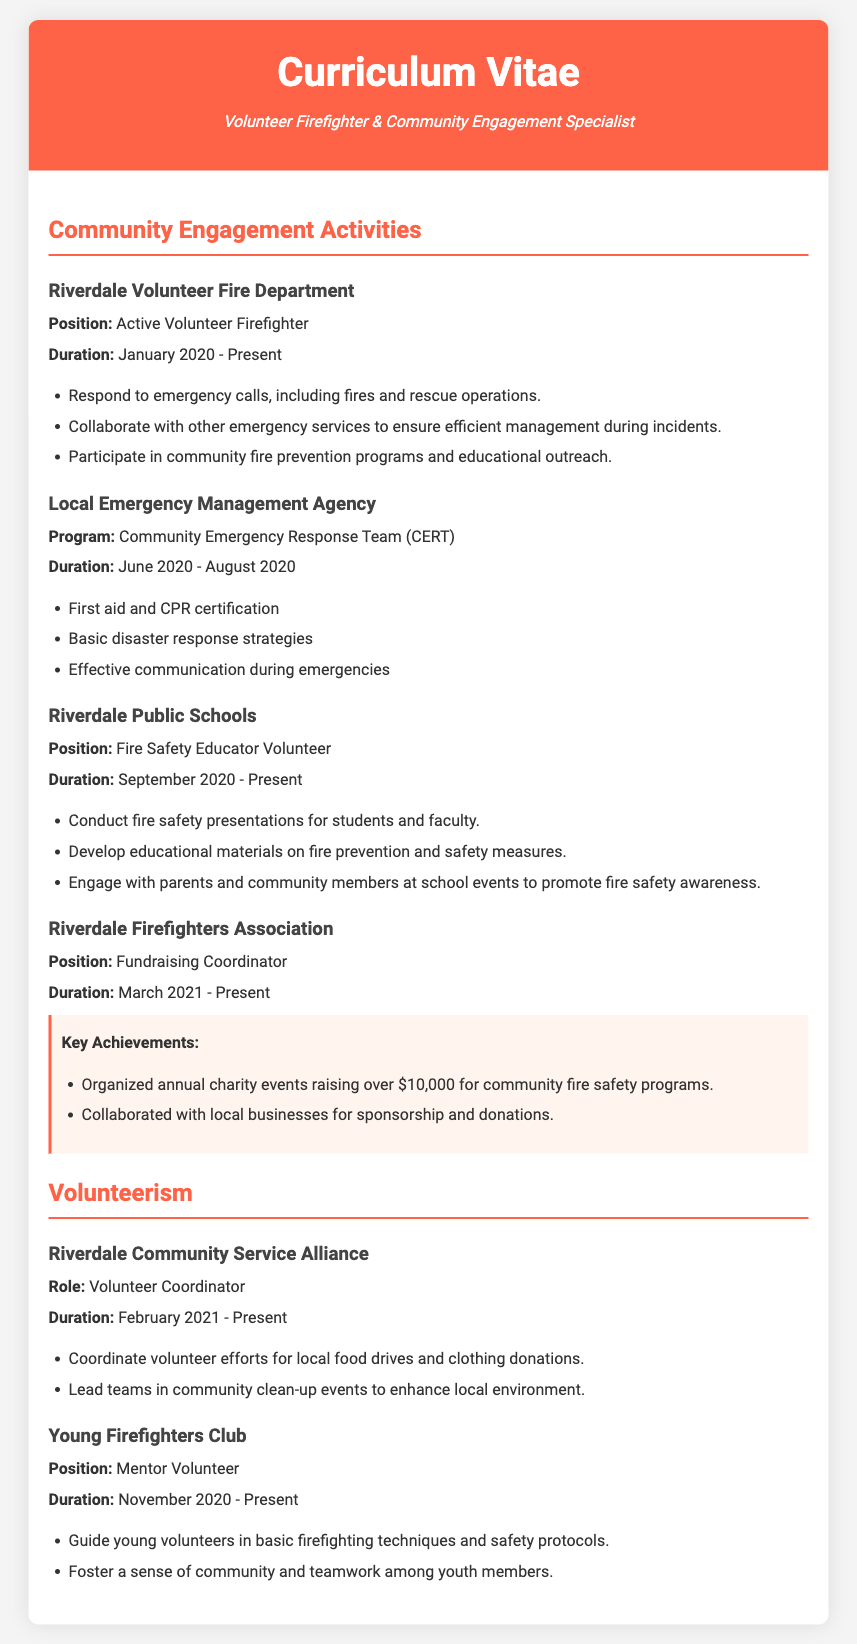what is the position held at Riverdale Volunteer Fire Department? The document states that the position is "Active Volunteer Firefighter."
Answer: Active Volunteer Firefighter what is the duration of service at Riverdale Public Schools? The duration mentioned is "September 2020 - Present."
Answer: September 2020 - Present how much money was raised through annual charity events by the Riverdale Firefighters Association? The key achievement noted is raising "over $10,000."
Answer: over $10,000 which program is associated with the Local Emergency Management Agency? The program listed is "Community Emergency Response Team (CERT)."
Answer: Community Emergency Response Team (CERT) what role is held at Riverdale Community Service Alliance? The document states the role is "Volunteer Coordinator."
Answer: Volunteer Coordinator how long has the Fire Safety Educator Volunteer position been held? The duration is noted as "September 2020 - Present."
Answer: September 2020 - Present what activities are coordinated by the Volunteer Coordinator? The document mentions coordinating "local food drives and clothing donations."
Answer: local food drives and clothing donations what type of volunteer work is done with the Young Firefighters Club? The position is described as "Mentor Volunteer."
Answer: Mentor Volunteer how many members lead teams in community clean-up events? The document specifies that the coordinator "lead teams," but does not provide a number.
Answer: N/A 